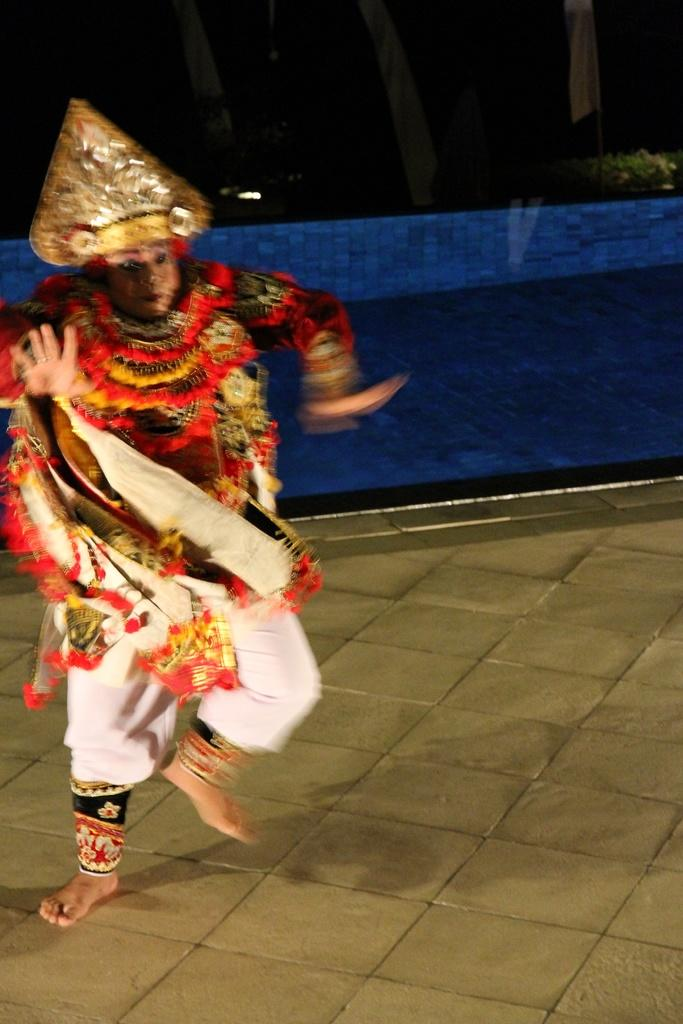What is the person in the image doing? The person in the image is running. What accessories is the person wearing? The person is wearing garlands and a crown. What type of clothing is the person wearing? The person is wearing different clothes. What month is depicted in the image? There is no specific month depicted in the image; it is a person running with garlands and a crown. How many boats can be seen in the image? There are no boats present in the image. 